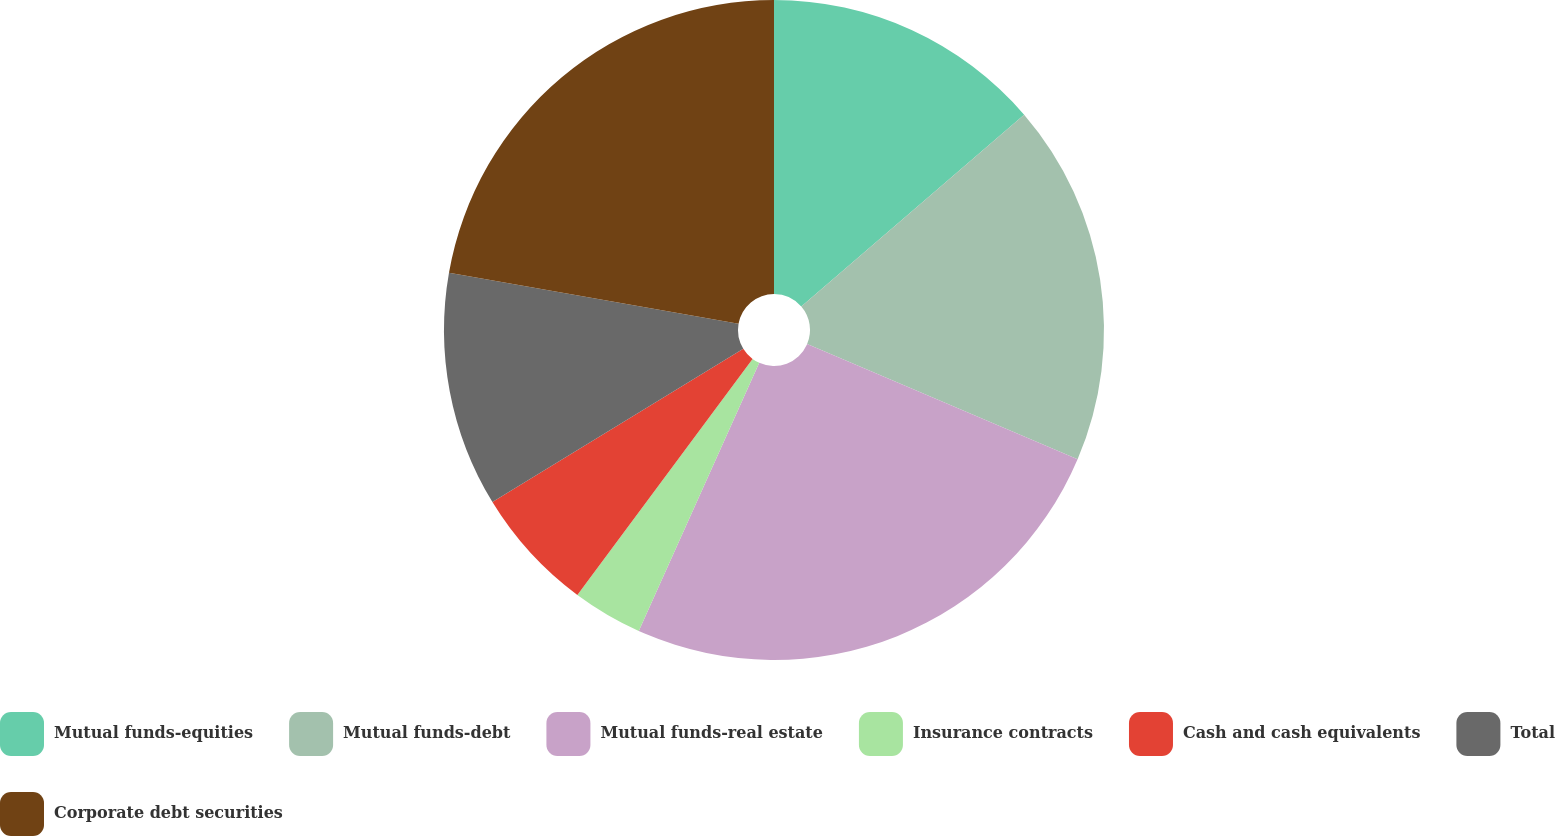<chart> <loc_0><loc_0><loc_500><loc_500><pie_chart><fcel>Mutual funds-equities<fcel>Mutual funds-debt<fcel>Mutual funds-real estate<fcel>Insurance contracts<fcel>Cash and cash equivalents<fcel>Total<fcel>Corporate debt securities<nl><fcel>13.69%<fcel>17.72%<fcel>25.31%<fcel>3.44%<fcel>6.11%<fcel>11.5%<fcel>22.23%<nl></chart> 